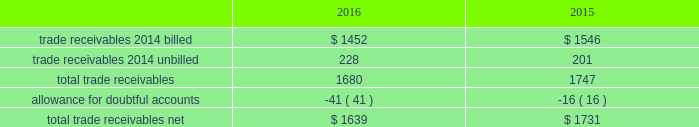Fidelity national information services , inc .
And subsidiaries notes to consolidated financial statements - ( continued ) contingent consideration liabilities recorded in connection with business acquisitions must also be adjusted for changes in fair value until settled .
See note 3 for discussion of the capital markets company bvba ( "capco" ) contingent consideration liability .
( d ) derivative financial instruments the company accounts for derivative financial instruments in accordance with financial accounting standards board accounting standards codification ( 201cfasb asc 201d ) topic 815 , derivatives and hedging .
During 2016 , 2015 and 2014 , the company engaged in g hedging activities relating to its variable rate debt through the use of interest rate swaps .
The company designates these interest rate swaps as cash flow hedges .
The estimated fair values of the cash flow hedges are determined using level 2 type measurements .
Thh ey are recorded as an asset or liability of the company and are included in the accompanying consolidated balance sheets in prepaid expenses and other current assets , other non-current assets , accounts payable and accrued liabilities or other long-term liabilities , as appropriate , and as a component of accumulated other comprehensive earnings , net of deferred taxes .
A portion of the amount included in accumulated other comprehensive earnings is recorded in interest expense as a yield adjustment as interest payments are made on then company 2019s term and revolving loans ( note 10 ) .
The company 2019s existing cash flow hedge is highly effective and there was no impact on 2016 earnings due to hedge ineffectiveness .
It is our policy to execute such instruments with credit-worthy banks and not to enter into derivative financial instruments for speculative purposes .
As of december 31 , 2016 , we believe that our interest rate swap counterparty will be able to fulfill its obligations under our agreement .
The company's foreign exchange risk management policy permits the use of derivative instruments , such as forward contracts and options , to reduce volatility in the company's results of operations and/or cash flows resulting from foreign exchange rate fluctuations .
During 2016 and 2015 , the company entered into foreign currency forward exchange contracts to hedge foreign currency exposure to intercompany loans .
As of december 31 , 2016 and 2015 , the notional amount of these derivatives was approximately $ 143 million and aa $ 81 million , respectively , and the fair value was nominal .
These derivatives have not been designated as hedges for accounting purposes .
We also use currency forward contracts to manage our exposure to fluctuations in costs caused by variations in indian rupee ( "inr" ) ii exchange rates .
As of december 31 , 2016 , the notional amount of these derivatives was approximately $ 7 million and the fair value was l less than $ 1 million , which is included in prepaid expenses and other current assets in the consolidated balance sheets .
These inr forward contracts are designated as cash flow hedges .
The fair value of these currency forward contracts is determined using currency uu exchange market rates , obtained from reliable , independent , third party banks , at the balance sheet date .
The fair value of forward rr contracts is subject to changes in currency exchange rates .
The company has no ineffectiveness related to its use of currency forward ff contracts in connection with inr cash flow hedges .
In september 2015 , the company entered into treasury lock hedges with a total notional amount of $ 1.0 billion , reducing the risk of changes in the benchmark index component of the 10-year treasury yield .
The company def signated these derivatives as cash flow hedges .
On october 13 , 2015 , in conjunction with the pricing of the $ 4.5 billion senior notes , the companyr terminated these treasury lock contracts for a cash settlement payment of $ 16 million , which was recorded as a component of other comprehensive earnings and will be reclassified as an adjustment to interest expense over the ten years during which the related interest payments that were hedged will be recognized in income .
( e ) trade receivables a summary of trade receivables , net , as of december 31 , 2016 and 2015 is as follows ( in millions ) : .

What was the percentage change in total trade receivables net from 2015 to 2016? 
Computations: ((1639 - 1731) / 1731)
Answer: -0.05315. 